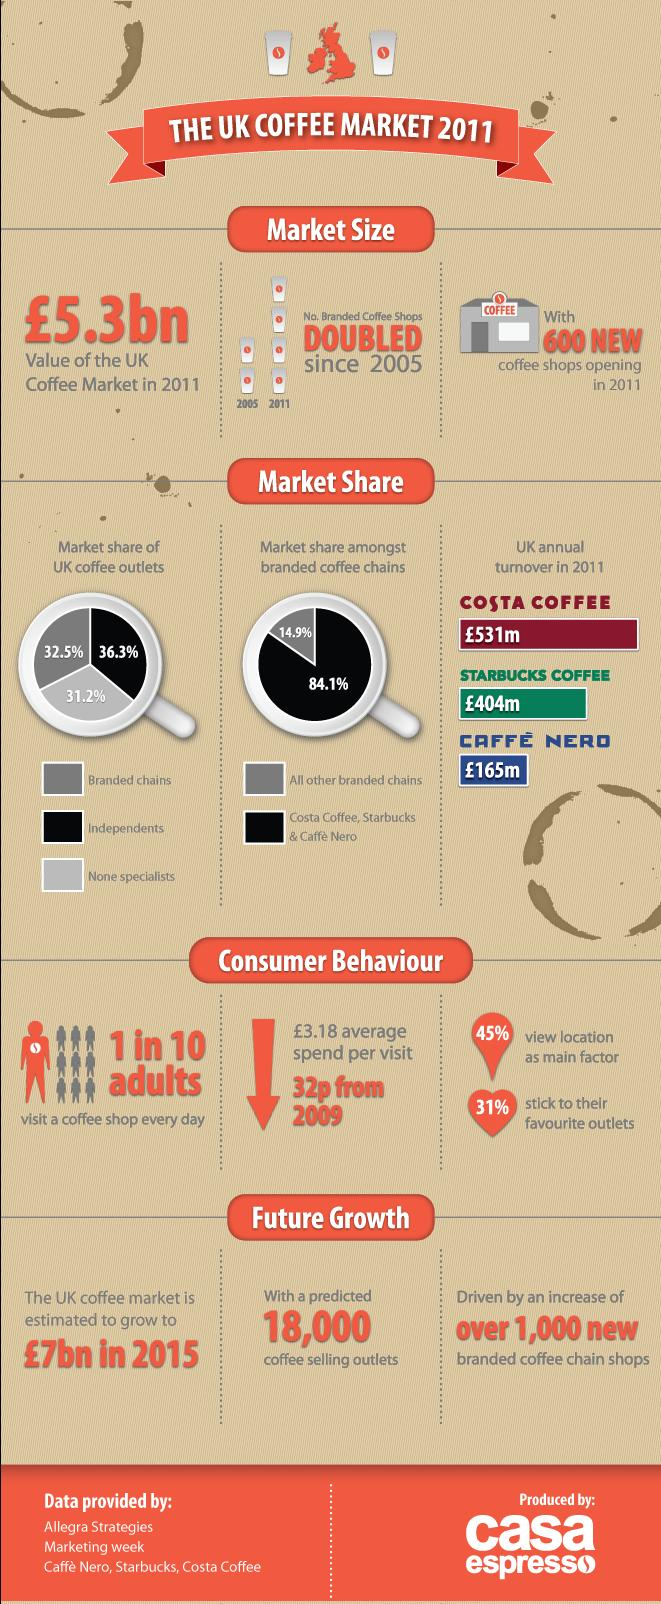Indicate a few pertinent items in this graphic. According to the data, a significant percentage of coffee outlets in the UK are independents, with 36.3% falling under this category. According to data from 2011, Starbucks Coffee is the second-ranking company among Costa Coffee, Starbucks Coffee, and Caffe Nero in terms of annual turnovers. The three branded chains, COSTA COFFEE, STARBUCKS COFFEE, and CAFFE NERO, hold the largest market share in the coffee industry. 